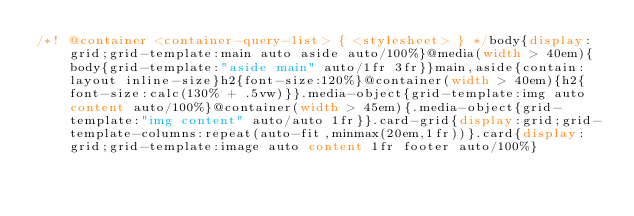Convert code to text. <code><loc_0><loc_0><loc_500><loc_500><_CSS_>/*! @container <container-query-list> { <stylesheet> } */body{display:grid;grid-template:main auto aside auto/100%}@media(width > 40em){body{grid-template:"aside main" auto/1fr 3fr}}main,aside{contain:layout inline-size}h2{font-size:120%}@container(width > 40em){h2{font-size:calc(130% + .5vw)}}.media-object{grid-template:img auto content auto/100%}@container(width > 45em){.media-object{grid-template:"img content" auto/auto 1fr}}.card-grid{display:grid;grid-template-columns:repeat(auto-fit,minmax(20em,1fr))}.card{display:grid;grid-template:image auto content 1fr footer auto/100%}</code> 